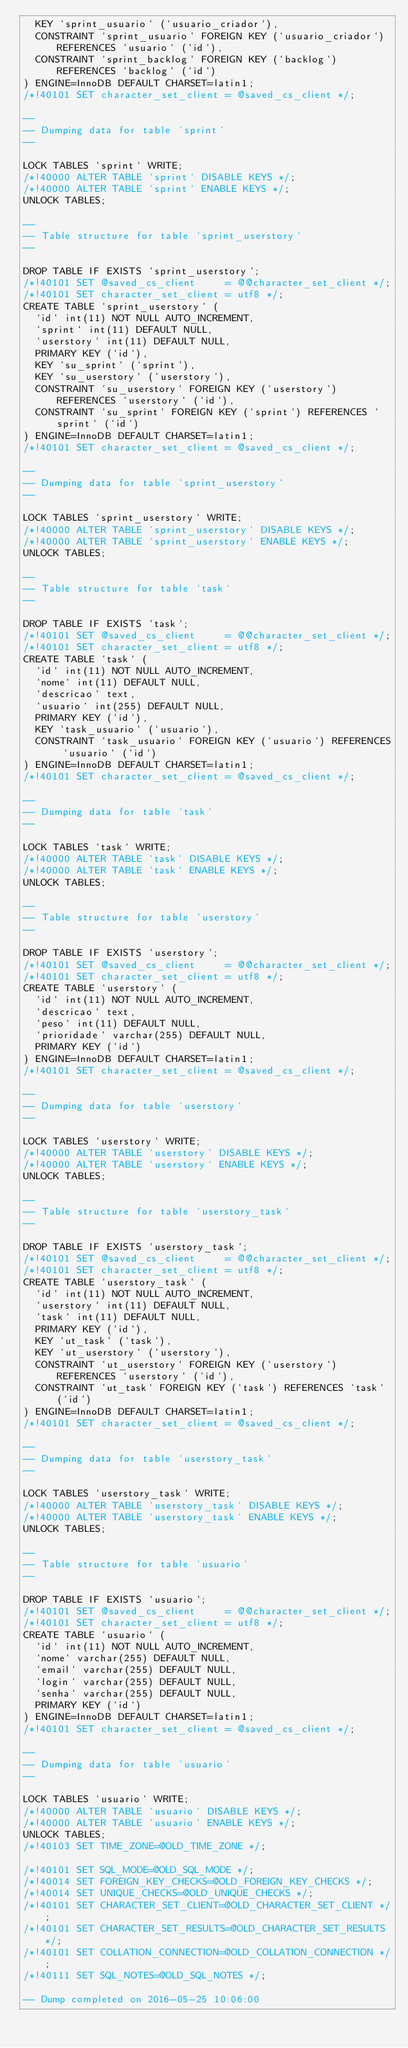<code> <loc_0><loc_0><loc_500><loc_500><_SQL_>  KEY `sprint_usuario` (`usuario_criador`),
  CONSTRAINT `sprint_usuario` FOREIGN KEY (`usuario_criador`) REFERENCES `usuario` (`id`),
  CONSTRAINT `sprint_backlog` FOREIGN KEY (`backlog`) REFERENCES `backlog` (`id`)
) ENGINE=InnoDB DEFAULT CHARSET=latin1;
/*!40101 SET character_set_client = @saved_cs_client */;

--
-- Dumping data for table `sprint`
--

LOCK TABLES `sprint` WRITE;
/*!40000 ALTER TABLE `sprint` DISABLE KEYS */;
/*!40000 ALTER TABLE `sprint` ENABLE KEYS */;
UNLOCK TABLES;

--
-- Table structure for table `sprint_userstory`
--

DROP TABLE IF EXISTS `sprint_userstory`;
/*!40101 SET @saved_cs_client     = @@character_set_client */;
/*!40101 SET character_set_client = utf8 */;
CREATE TABLE `sprint_userstory` (
  `id` int(11) NOT NULL AUTO_INCREMENT,
  `sprint` int(11) DEFAULT NULL,
  `userstory` int(11) DEFAULT NULL,
  PRIMARY KEY (`id`),
  KEY `su_sprint` (`sprint`),
  KEY `su_userstory` (`userstory`),
  CONSTRAINT `su_userstory` FOREIGN KEY (`userstory`) REFERENCES `userstory` (`id`),
  CONSTRAINT `su_sprint` FOREIGN KEY (`sprint`) REFERENCES `sprint` (`id`)
) ENGINE=InnoDB DEFAULT CHARSET=latin1;
/*!40101 SET character_set_client = @saved_cs_client */;

--
-- Dumping data for table `sprint_userstory`
--

LOCK TABLES `sprint_userstory` WRITE;
/*!40000 ALTER TABLE `sprint_userstory` DISABLE KEYS */;
/*!40000 ALTER TABLE `sprint_userstory` ENABLE KEYS */;
UNLOCK TABLES;

--
-- Table structure for table `task`
--

DROP TABLE IF EXISTS `task`;
/*!40101 SET @saved_cs_client     = @@character_set_client */;
/*!40101 SET character_set_client = utf8 */;
CREATE TABLE `task` (
  `id` int(11) NOT NULL AUTO_INCREMENT,
  `nome` int(11) DEFAULT NULL,
  `descricao` text,
  `usuario` int(255) DEFAULT NULL,
  PRIMARY KEY (`id`),
  KEY `task_usuario` (`usuario`),
  CONSTRAINT `task_usuario` FOREIGN KEY (`usuario`) REFERENCES `usuario` (`id`)
) ENGINE=InnoDB DEFAULT CHARSET=latin1;
/*!40101 SET character_set_client = @saved_cs_client */;

--
-- Dumping data for table `task`
--

LOCK TABLES `task` WRITE;
/*!40000 ALTER TABLE `task` DISABLE KEYS */;
/*!40000 ALTER TABLE `task` ENABLE KEYS */;
UNLOCK TABLES;

--
-- Table structure for table `userstory`
--

DROP TABLE IF EXISTS `userstory`;
/*!40101 SET @saved_cs_client     = @@character_set_client */;
/*!40101 SET character_set_client = utf8 */;
CREATE TABLE `userstory` (
  `id` int(11) NOT NULL AUTO_INCREMENT,
  `descricao` text,
  `peso` int(11) DEFAULT NULL,
  `prioridade` varchar(255) DEFAULT NULL,
  PRIMARY KEY (`id`)
) ENGINE=InnoDB DEFAULT CHARSET=latin1;
/*!40101 SET character_set_client = @saved_cs_client */;

--
-- Dumping data for table `userstory`
--

LOCK TABLES `userstory` WRITE;
/*!40000 ALTER TABLE `userstory` DISABLE KEYS */;
/*!40000 ALTER TABLE `userstory` ENABLE KEYS */;
UNLOCK TABLES;

--
-- Table structure for table `userstory_task`
--

DROP TABLE IF EXISTS `userstory_task`;
/*!40101 SET @saved_cs_client     = @@character_set_client */;
/*!40101 SET character_set_client = utf8 */;
CREATE TABLE `userstory_task` (
  `id` int(11) NOT NULL AUTO_INCREMENT,
  `userstory` int(11) DEFAULT NULL,
  `task` int(11) DEFAULT NULL,
  PRIMARY KEY (`id`),
  KEY `ut_task` (`task`),
  KEY `ut_userstory` (`userstory`),
  CONSTRAINT `ut_userstory` FOREIGN KEY (`userstory`) REFERENCES `userstory` (`id`),
  CONSTRAINT `ut_task` FOREIGN KEY (`task`) REFERENCES `task` (`id`)
) ENGINE=InnoDB DEFAULT CHARSET=latin1;
/*!40101 SET character_set_client = @saved_cs_client */;

--
-- Dumping data for table `userstory_task`
--

LOCK TABLES `userstory_task` WRITE;
/*!40000 ALTER TABLE `userstory_task` DISABLE KEYS */;
/*!40000 ALTER TABLE `userstory_task` ENABLE KEYS */;
UNLOCK TABLES;

--
-- Table structure for table `usuario`
--

DROP TABLE IF EXISTS `usuario`;
/*!40101 SET @saved_cs_client     = @@character_set_client */;
/*!40101 SET character_set_client = utf8 */;
CREATE TABLE `usuario` (
  `id` int(11) NOT NULL AUTO_INCREMENT,
  `nome` varchar(255) DEFAULT NULL,
  `email` varchar(255) DEFAULT NULL,
  `login` varchar(255) DEFAULT NULL,
  `senha` varchar(255) DEFAULT NULL,
  PRIMARY KEY (`id`)
) ENGINE=InnoDB DEFAULT CHARSET=latin1;
/*!40101 SET character_set_client = @saved_cs_client */;

--
-- Dumping data for table `usuario`
--

LOCK TABLES `usuario` WRITE;
/*!40000 ALTER TABLE `usuario` DISABLE KEYS */;
/*!40000 ALTER TABLE `usuario` ENABLE KEYS */;
UNLOCK TABLES;
/*!40103 SET TIME_ZONE=@OLD_TIME_ZONE */;

/*!40101 SET SQL_MODE=@OLD_SQL_MODE */;
/*!40014 SET FOREIGN_KEY_CHECKS=@OLD_FOREIGN_KEY_CHECKS */;
/*!40014 SET UNIQUE_CHECKS=@OLD_UNIQUE_CHECKS */;
/*!40101 SET CHARACTER_SET_CLIENT=@OLD_CHARACTER_SET_CLIENT */;
/*!40101 SET CHARACTER_SET_RESULTS=@OLD_CHARACTER_SET_RESULTS */;
/*!40101 SET COLLATION_CONNECTION=@OLD_COLLATION_CONNECTION */;
/*!40111 SET SQL_NOTES=@OLD_SQL_NOTES */;

-- Dump completed on 2016-05-25 10:06:00
</code> 